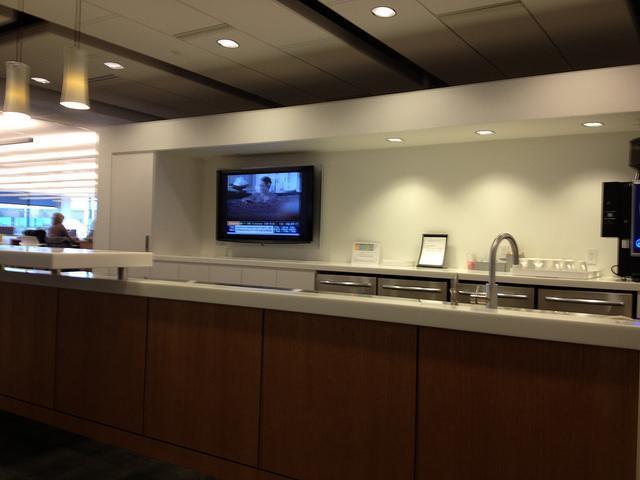How many TVs is in the picture?
Give a very brief answer. 1. How many people does the pizza feed?
Give a very brief answer. 0. 